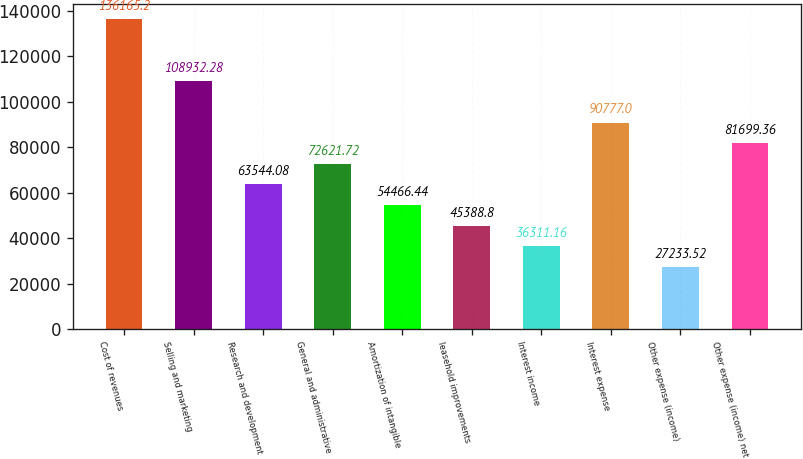Convert chart to OTSL. <chart><loc_0><loc_0><loc_500><loc_500><bar_chart><fcel>Cost of revenues<fcel>Selling and marketing<fcel>Research and development<fcel>General and administrative<fcel>Amortization of intangible<fcel>leasehold improvements<fcel>Interest income<fcel>Interest expense<fcel>Other expense (income)<fcel>Other expense (income) net<nl><fcel>136165<fcel>108932<fcel>63544.1<fcel>72621.7<fcel>54466.4<fcel>45388.8<fcel>36311.2<fcel>90777<fcel>27233.5<fcel>81699.4<nl></chart> 